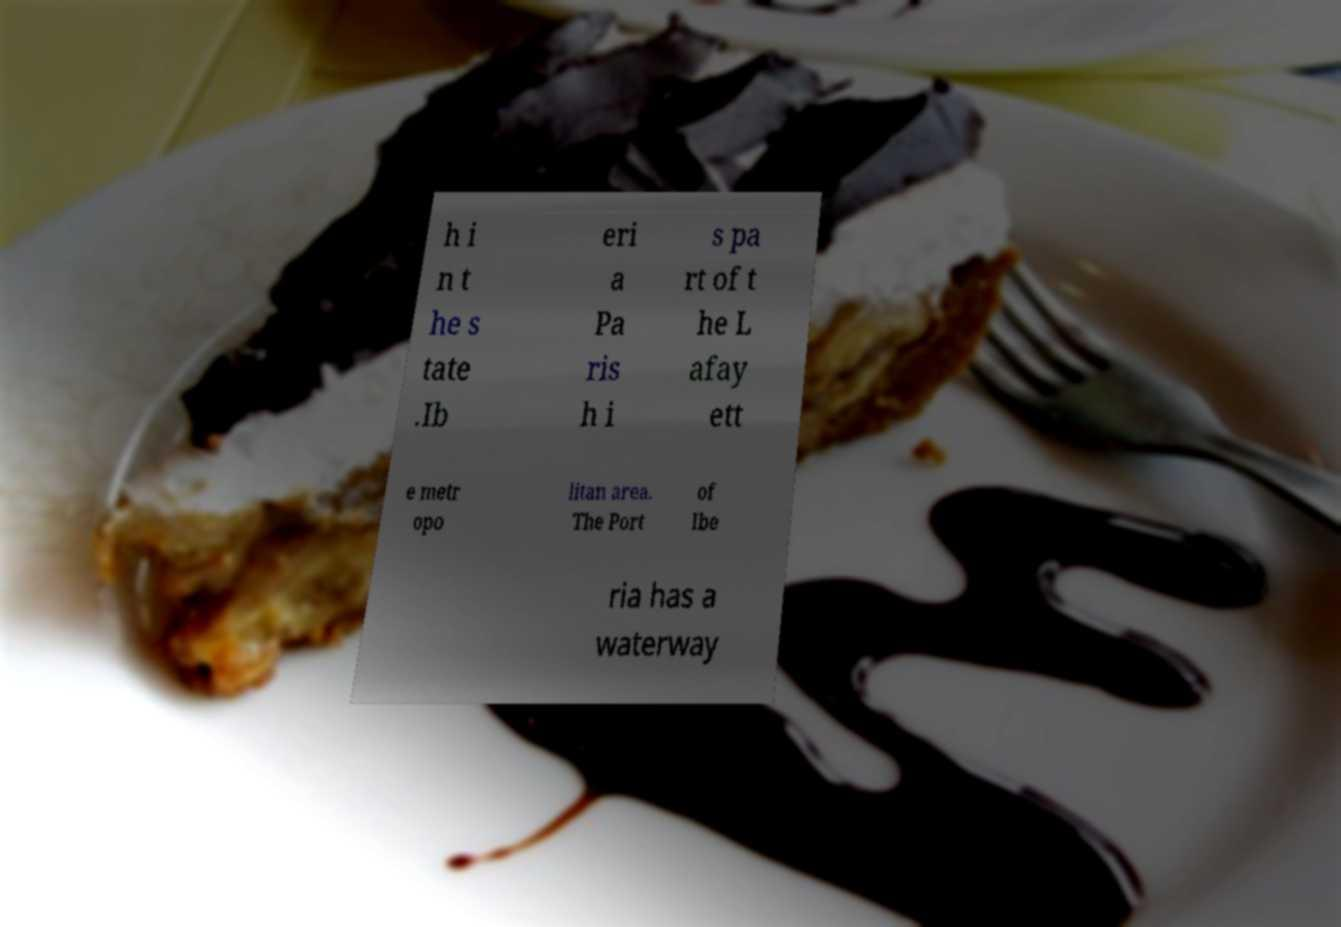What messages or text are displayed in this image? I need them in a readable, typed format. h i n t he s tate .Ib eri a Pa ris h i s pa rt of t he L afay ett e metr opo litan area. The Port of Ibe ria has a waterway 